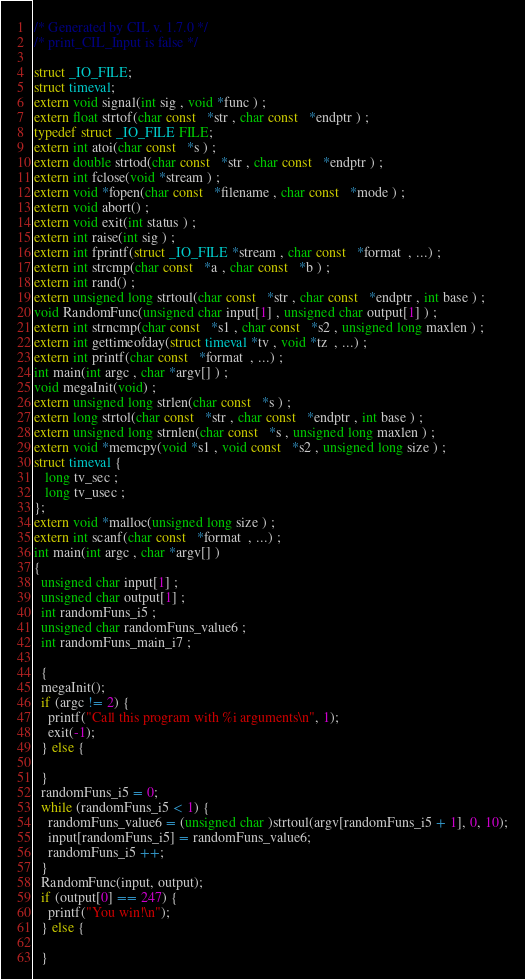Convert code to text. <code><loc_0><loc_0><loc_500><loc_500><_C_>/* Generated by CIL v. 1.7.0 */
/* print_CIL_Input is false */

struct _IO_FILE;
struct timeval;
extern void signal(int sig , void *func ) ;
extern float strtof(char const   *str , char const   *endptr ) ;
typedef struct _IO_FILE FILE;
extern int atoi(char const   *s ) ;
extern double strtod(char const   *str , char const   *endptr ) ;
extern int fclose(void *stream ) ;
extern void *fopen(char const   *filename , char const   *mode ) ;
extern void abort() ;
extern void exit(int status ) ;
extern int raise(int sig ) ;
extern int fprintf(struct _IO_FILE *stream , char const   *format  , ...) ;
extern int strcmp(char const   *a , char const   *b ) ;
extern int rand() ;
extern unsigned long strtoul(char const   *str , char const   *endptr , int base ) ;
void RandomFunc(unsigned char input[1] , unsigned char output[1] ) ;
extern int strncmp(char const   *s1 , char const   *s2 , unsigned long maxlen ) ;
extern int gettimeofday(struct timeval *tv , void *tz  , ...) ;
extern int printf(char const   *format  , ...) ;
int main(int argc , char *argv[] ) ;
void megaInit(void) ;
extern unsigned long strlen(char const   *s ) ;
extern long strtol(char const   *str , char const   *endptr , int base ) ;
extern unsigned long strnlen(char const   *s , unsigned long maxlen ) ;
extern void *memcpy(void *s1 , void const   *s2 , unsigned long size ) ;
struct timeval {
   long tv_sec ;
   long tv_usec ;
};
extern void *malloc(unsigned long size ) ;
extern int scanf(char const   *format  , ...) ;
int main(int argc , char *argv[] ) 
{ 
  unsigned char input[1] ;
  unsigned char output[1] ;
  int randomFuns_i5 ;
  unsigned char randomFuns_value6 ;
  int randomFuns_main_i7 ;

  {
  megaInit();
  if (argc != 2) {
    printf("Call this program with %i arguments\n", 1);
    exit(-1);
  } else {

  }
  randomFuns_i5 = 0;
  while (randomFuns_i5 < 1) {
    randomFuns_value6 = (unsigned char )strtoul(argv[randomFuns_i5 + 1], 0, 10);
    input[randomFuns_i5] = randomFuns_value6;
    randomFuns_i5 ++;
  }
  RandomFunc(input, output);
  if (output[0] == 247) {
    printf("You win!\n");
  } else {

  }</code> 